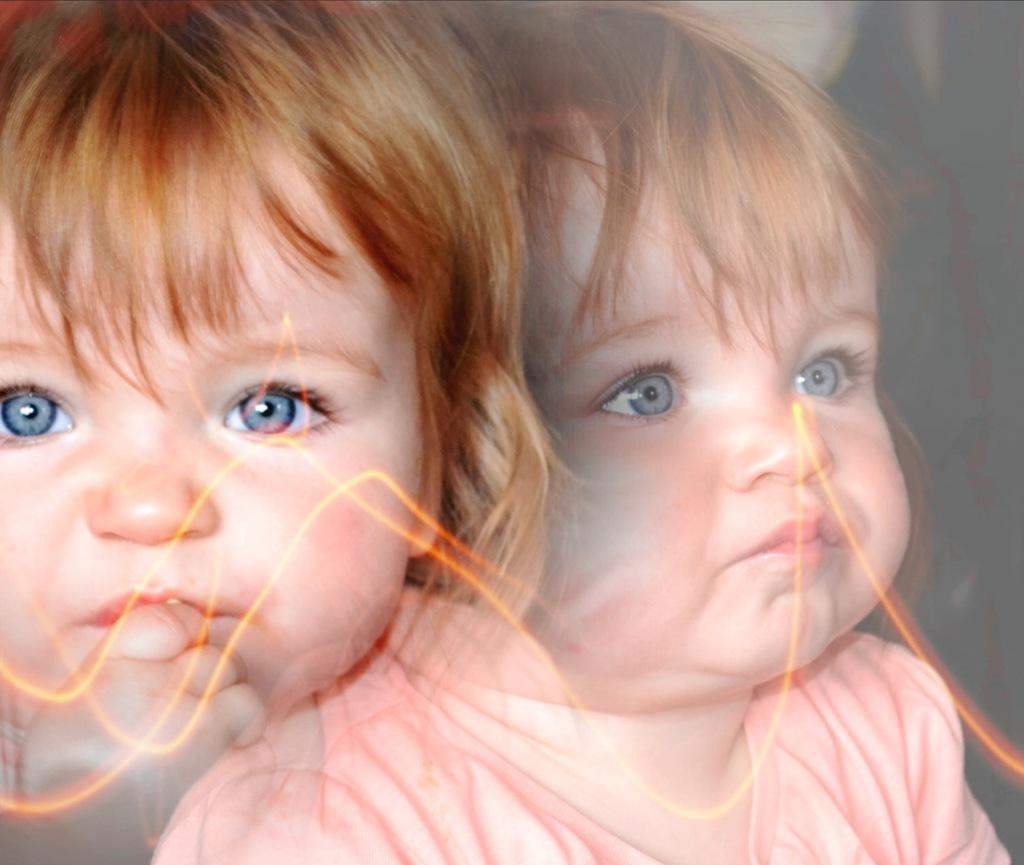What is the main subject of the image? The main subject of the image is a picture of a child. What is the child doing in the image? The child is putting her finger on her lip. What type of joke is the child telling in the image? There is no indication in the image that the child is telling a joke, as she is simply putting her finger on her lip. 